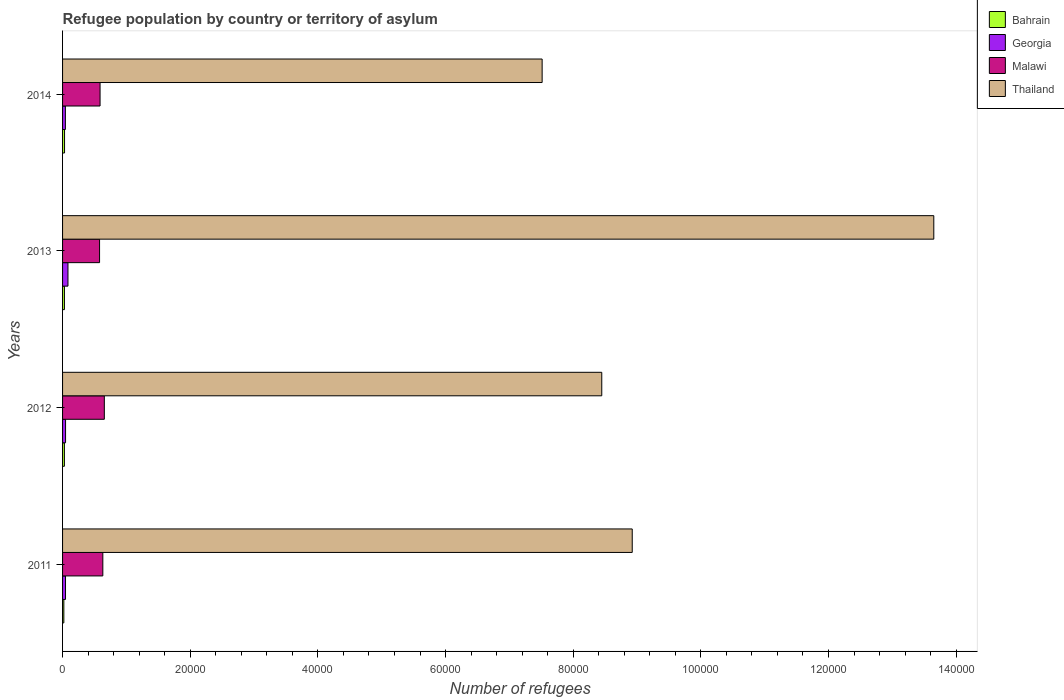How many different coloured bars are there?
Give a very brief answer. 4. How many groups of bars are there?
Your response must be concise. 4. Are the number of bars on each tick of the Y-axis equal?
Your answer should be very brief. Yes. How many bars are there on the 2nd tick from the top?
Keep it short and to the point. 4. How many bars are there on the 4th tick from the bottom?
Give a very brief answer. 4. What is the label of the 1st group of bars from the top?
Make the answer very short. 2014. In how many cases, is the number of bars for a given year not equal to the number of legend labels?
Your answer should be compact. 0. What is the number of refugees in Bahrain in 2014?
Offer a terse response. 311. Across all years, what is the maximum number of refugees in Bahrain?
Keep it short and to the point. 311. Across all years, what is the minimum number of refugees in Bahrain?
Keep it short and to the point. 199. In which year was the number of refugees in Malawi maximum?
Make the answer very short. 2012. What is the total number of refugees in Thailand in the graph?
Your answer should be very brief. 3.85e+05. What is the difference between the number of refugees in Bahrain in 2011 and that in 2012?
Keep it short and to the point. -90. What is the difference between the number of refugees in Georgia in 2011 and the number of refugees in Bahrain in 2013?
Offer a terse response. 168. What is the average number of refugees in Thailand per year?
Ensure brevity in your answer.  9.63e+04. In the year 2013, what is the difference between the number of refugees in Malawi and number of refugees in Georgia?
Keep it short and to the point. 4949. What is the ratio of the number of refugees in Bahrain in 2011 to that in 2012?
Your answer should be compact. 0.69. What is the difference between the highest and the lowest number of refugees in Thailand?
Provide a succinct answer. 6.14e+04. In how many years, is the number of refugees in Bahrain greater than the average number of refugees in Bahrain taken over all years?
Your answer should be compact. 3. Is the sum of the number of refugees in Thailand in 2013 and 2014 greater than the maximum number of refugees in Malawi across all years?
Your response must be concise. Yes. Is it the case that in every year, the sum of the number of refugees in Georgia and number of refugees in Malawi is greater than the sum of number of refugees in Thailand and number of refugees in Bahrain?
Offer a terse response. Yes. What does the 3rd bar from the top in 2013 represents?
Give a very brief answer. Georgia. What does the 1st bar from the bottom in 2014 represents?
Ensure brevity in your answer.  Bahrain. How many bars are there?
Offer a very short reply. 16. Are all the bars in the graph horizontal?
Make the answer very short. Yes. How many years are there in the graph?
Offer a terse response. 4. Are the values on the major ticks of X-axis written in scientific E-notation?
Keep it short and to the point. No. Does the graph contain any zero values?
Your response must be concise. No. Does the graph contain grids?
Ensure brevity in your answer.  No. How many legend labels are there?
Provide a short and direct response. 4. What is the title of the graph?
Ensure brevity in your answer.  Refugee population by country or territory of asylum. Does "Vanuatu" appear as one of the legend labels in the graph?
Provide a succinct answer. No. What is the label or title of the X-axis?
Give a very brief answer. Number of refugees. What is the label or title of the Y-axis?
Your answer should be very brief. Years. What is the Number of refugees of Bahrain in 2011?
Provide a succinct answer. 199. What is the Number of refugees in Georgia in 2011?
Make the answer very short. 462. What is the Number of refugees in Malawi in 2011?
Your answer should be very brief. 6308. What is the Number of refugees of Thailand in 2011?
Your response must be concise. 8.93e+04. What is the Number of refugees in Bahrain in 2012?
Offer a very short reply. 289. What is the Number of refugees in Georgia in 2012?
Make the answer very short. 469. What is the Number of refugees in Malawi in 2012?
Offer a very short reply. 6544. What is the Number of refugees of Thailand in 2012?
Provide a short and direct response. 8.45e+04. What is the Number of refugees in Bahrain in 2013?
Your answer should be very brief. 294. What is the Number of refugees in Georgia in 2013?
Offer a terse response. 847. What is the Number of refugees of Malawi in 2013?
Provide a short and direct response. 5796. What is the Number of refugees in Thailand in 2013?
Your response must be concise. 1.36e+05. What is the Number of refugees of Bahrain in 2014?
Your answer should be compact. 311. What is the Number of refugees of Georgia in 2014?
Make the answer very short. 442. What is the Number of refugees in Malawi in 2014?
Your answer should be compact. 5874. What is the Number of refugees in Thailand in 2014?
Give a very brief answer. 7.51e+04. Across all years, what is the maximum Number of refugees of Bahrain?
Provide a short and direct response. 311. Across all years, what is the maximum Number of refugees of Georgia?
Provide a short and direct response. 847. Across all years, what is the maximum Number of refugees of Malawi?
Make the answer very short. 6544. Across all years, what is the maximum Number of refugees in Thailand?
Provide a succinct answer. 1.36e+05. Across all years, what is the minimum Number of refugees in Bahrain?
Make the answer very short. 199. Across all years, what is the minimum Number of refugees of Georgia?
Ensure brevity in your answer.  442. Across all years, what is the minimum Number of refugees in Malawi?
Keep it short and to the point. 5796. Across all years, what is the minimum Number of refugees in Thailand?
Provide a succinct answer. 7.51e+04. What is the total Number of refugees of Bahrain in the graph?
Your answer should be very brief. 1093. What is the total Number of refugees in Georgia in the graph?
Provide a short and direct response. 2220. What is the total Number of refugees in Malawi in the graph?
Offer a terse response. 2.45e+04. What is the total Number of refugees of Thailand in the graph?
Give a very brief answer. 3.85e+05. What is the difference between the Number of refugees in Bahrain in 2011 and that in 2012?
Your answer should be very brief. -90. What is the difference between the Number of refugees in Georgia in 2011 and that in 2012?
Offer a terse response. -7. What is the difference between the Number of refugees of Malawi in 2011 and that in 2012?
Make the answer very short. -236. What is the difference between the Number of refugees of Thailand in 2011 and that in 2012?
Offer a terse response. 4774. What is the difference between the Number of refugees of Bahrain in 2011 and that in 2013?
Give a very brief answer. -95. What is the difference between the Number of refugees of Georgia in 2011 and that in 2013?
Make the answer very short. -385. What is the difference between the Number of refugees of Malawi in 2011 and that in 2013?
Provide a short and direct response. 512. What is the difference between the Number of refugees in Thailand in 2011 and that in 2013?
Provide a short and direct response. -4.72e+04. What is the difference between the Number of refugees in Bahrain in 2011 and that in 2014?
Keep it short and to the point. -112. What is the difference between the Number of refugees in Malawi in 2011 and that in 2014?
Offer a terse response. 434. What is the difference between the Number of refugees of Thailand in 2011 and that in 2014?
Make the answer very short. 1.41e+04. What is the difference between the Number of refugees of Bahrain in 2012 and that in 2013?
Provide a short and direct response. -5. What is the difference between the Number of refugees of Georgia in 2012 and that in 2013?
Provide a short and direct response. -378. What is the difference between the Number of refugees in Malawi in 2012 and that in 2013?
Give a very brief answer. 748. What is the difference between the Number of refugees of Thailand in 2012 and that in 2013?
Ensure brevity in your answer.  -5.20e+04. What is the difference between the Number of refugees in Malawi in 2012 and that in 2014?
Make the answer very short. 670. What is the difference between the Number of refugees of Thailand in 2012 and that in 2014?
Your answer should be compact. 9342. What is the difference between the Number of refugees of Georgia in 2013 and that in 2014?
Your answer should be compact. 405. What is the difference between the Number of refugees of Malawi in 2013 and that in 2014?
Ensure brevity in your answer.  -78. What is the difference between the Number of refugees of Thailand in 2013 and that in 2014?
Ensure brevity in your answer.  6.14e+04. What is the difference between the Number of refugees of Bahrain in 2011 and the Number of refugees of Georgia in 2012?
Make the answer very short. -270. What is the difference between the Number of refugees in Bahrain in 2011 and the Number of refugees in Malawi in 2012?
Your answer should be very brief. -6345. What is the difference between the Number of refugees of Bahrain in 2011 and the Number of refugees of Thailand in 2012?
Make the answer very short. -8.43e+04. What is the difference between the Number of refugees of Georgia in 2011 and the Number of refugees of Malawi in 2012?
Keep it short and to the point. -6082. What is the difference between the Number of refugees of Georgia in 2011 and the Number of refugees of Thailand in 2012?
Provide a short and direct response. -8.40e+04. What is the difference between the Number of refugees of Malawi in 2011 and the Number of refugees of Thailand in 2012?
Your answer should be compact. -7.82e+04. What is the difference between the Number of refugees in Bahrain in 2011 and the Number of refugees in Georgia in 2013?
Provide a short and direct response. -648. What is the difference between the Number of refugees in Bahrain in 2011 and the Number of refugees in Malawi in 2013?
Offer a terse response. -5597. What is the difference between the Number of refugees in Bahrain in 2011 and the Number of refugees in Thailand in 2013?
Keep it short and to the point. -1.36e+05. What is the difference between the Number of refugees of Georgia in 2011 and the Number of refugees of Malawi in 2013?
Your response must be concise. -5334. What is the difference between the Number of refugees in Georgia in 2011 and the Number of refugees in Thailand in 2013?
Make the answer very short. -1.36e+05. What is the difference between the Number of refugees in Malawi in 2011 and the Number of refugees in Thailand in 2013?
Provide a short and direct response. -1.30e+05. What is the difference between the Number of refugees in Bahrain in 2011 and the Number of refugees in Georgia in 2014?
Your answer should be compact. -243. What is the difference between the Number of refugees in Bahrain in 2011 and the Number of refugees in Malawi in 2014?
Your answer should be very brief. -5675. What is the difference between the Number of refugees of Bahrain in 2011 and the Number of refugees of Thailand in 2014?
Provide a short and direct response. -7.49e+04. What is the difference between the Number of refugees of Georgia in 2011 and the Number of refugees of Malawi in 2014?
Provide a short and direct response. -5412. What is the difference between the Number of refugees in Georgia in 2011 and the Number of refugees in Thailand in 2014?
Make the answer very short. -7.47e+04. What is the difference between the Number of refugees in Malawi in 2011 and the Number of refugees in Thailand in 2014?
Your response must be concise. -6.88e+04. What is the difference between the Number of refugees of Bahrain in 2012 and the Number of refugees of Georgia in 2013?
Your response must be concise. -558. What is the difference between the Number of refugees in Bahrain in 2012 and the Number of refugees in Malawi in 2013?
Keep it short and to the point. -5507. What is the difference between the Number of refugees of Bahrain in 2012 and the Number of refugees of Thailand in 2013?
Make the answer very short. -1.36e+05. What is the difference between the Number of refugees of Georgia in 2012 and the Number of refugees of Malawi in 2013?
Your answer should be compact. -5327. What is the difference between the Number of refugees in Georgia in 2012 and the Number of refugees in Thailand in 2013?
Ensure brevity in your answer.  -1.36e+05. What is the difference between the Number of refugees in Malawi in 2012 and the Number of refugees in Thailand in 2013?
Offer a terse response. -1.30e+05. What is the difference between the Number of refugees of Bahrain in 2012 and the Number of refugees of Georgia in 2014?
Offer a very short reply. -153. What is the difference between the Number of refugees in Bahrain in 2012 and the Number of refugees in Malawi in 2014?
Make the answer very short. -5585. What is the difference between the Number of refugees of Bahrain in 2012 and the Number of refugees of Thailand in 2014?
Provide a succinct answer. -7.48e+04. What is the difference between the Number of refugees in Georgia in 2012 and the Number of refugees in Malawi in 2014?
Your answer should be compact. -5405. What is the difference between the Number of refugees of Georgia in 2012 and the Number of refugees of Thailand in 2014?
Your response must be concise. -7.47e+04. What is the difference between the Number of refugees of Malawi in 2012 and the Number of refugees of Thailand in 2014?
Make the answer very short. -6.86e+04. What is the difference between the Number of refugees in Bahrain in 2013 and the Number of refugees in Georgia in 2014?
Your answer should be very brief. -148. What is the difference between the Number of refugees in Bahrain in 2013 and the Number of refugees in Malawi in 2014?
Keep it short and to the point. -5580. What is the difference between the Number of refugees in Bahrain in 2013 and the Number of refugees in Thailand in 2014?
Keep it short and to the point. -7.48e+04. What is the difference between the Number of refugees of Georgia in 2013 and the Number of refugees of Malawi in 2014?
Provide a short and direct response. -5027. What is the difference between the Number of refugees in Georgia in 2013 and the Number of refugees in Thailand in 2014?
Your answer should be very brief. -7.43e+04. What is the difference between the Number of refugees of Malawi in 2013 and the Number of refugees of Thailand in 2014?
Offer a terse response. -6.93e+04. What is the average Number of refugees of Bahrain per year?
Provide a succinct answer. 273.25. What is the average Number of refugees of Georgia per year?
Provide a short and direct response. 555. What is the average Number of refugees of Malawi per year?
Offer a terse response. 6130.5. What is the average Number of refugees of Thailand per year?
Your answer should be very brief. 9.63e+04. In the year 2011, what is the difference between the Number of refugees in Bahrain and Number of refugees in Georgia?
Your answer should be very brief. -263. In the year 2011, what is the difference between the Number of refugees of Bahrain and Number of refugees of Malawi?
Offer a very short reply. -6109. In the year 2011, what is the difference between the Number of refugees in Bahrain and Number of refugees in Thailand?
Provide a succinct answer. -8.91e+04. In the year 2011, what is the difference between the Number of refugees of Georgia and Number of refugees of Malawi?
Your response must be concise. -5846. In the year 2011, what is the difference between the Number of refugees in Georgia and Number of refugees in Thailand?
Your answer should be very brief. -8.88e+04. In the year 2011, what is the difference between the Number of refugees of Malawi and Number of refugees of Thailand?
Offer a terse response. -8.29e+04. In the year 2012, what is the difference between the Number of refugees in Bahrain and Number of refugees in Georgia?
Your answer should be compact. -180. In the year 2012, what is the difference between the Number of refugees of Bahrain and Number of refugees of Malawi?
Your response must be concise. -6255. In the year 2012, what is the difference between the Number of refugees of Bahrain and Number of refugees of Thailand?
Offer a terse response. -8.42e+04. In the year 2012, what is the difference between the Number of refugees in Georgia and Number of refugees in Malawi?
Offer a very short reply. -6075. In the year 2012, what is the difference between the Number of refugees in Georgia and Number of refugees in Thailand?
Offer a very short reply. -8.40e+04. In the year 2012, what is the difference between the Number of refugees in Malawi and Number of refugees in Thailand?
Give a very brief answer. -7.79e+04. In the year 2013, what is the difference between the Number of refugees in Bahrain and Number of refugees in Georgia?
Give a very brief answer. -553. In the year 2013, what is the difference between the Number of refugees in Bahrain and Number of refugees in Malawi?
Your answer should be compact. -5502. In the year 2013, what is the difference between the Number of refugees in Bahrain and Number of refugees in Thailand?
Ensure brevity in your answer.  -1.36e+05. In the year 2013, what is the difference between the Number of refugees in Georgia and Number of refugees in Malawi?
Keep it short and to the point. -4949. In the year 2013, what is the difference between the Number of refugees of Georgia and Number of refugees of Thailand?
Offer a terse response. -1.36e+05. In the year 2013, what is the difference between the Number of refugees of Malawi and Number of refugees of Thailand?
Your response must be concise. -1.31e+05. In the year 2014, what is the difference between the Number of refugees in Bahrain and Number of refugees in Georgia?
Provide a succinct answer. -131. In the year 2014, what is the difference between the Number of refugees in Bahrain and Number of refugees in Malawi?
Your answer should be very brief. -5563. In the year 2014, what is the difference between the Number of refugees in Bahrain and Number of refugees in Thailand?
Offer a terse response. -7.48e+04. In the year 2014, what is the difference between the Number of refugees in Georgia and Number of refugees in Malawi?
Give a very brief answer. -5432. In the year 2014, what is the difference between the Number of refugees in Georgia and Number of refugees in Thailand?
Your answer should be very brief. -7.47e+04. In the year 2014, what is the difference between the Number of refugees of Malawi and Number of refugees of Thailand?
Keep it short and to the point. -6.93e+04. What is the ratio of the Number of refugees of Bahrain in 2011 to that in 2012?
Offer a very short reply. 0.69. What is the ratio of the Number of refugees in Georgia in 2011 to that in 2012?
Provide a short and direct response. 0.99. What is the ratio of the Number of refugees of Malawi in 2011 to that in 2012?
Give a very brief answer. 0.96. What is the ratio of the Number of refugees in Thailand in 2011 to that in 2012?
Offer a terse response. 1.06. What is the ratio of the Number of refugees of Bahrain in 2011 to that in 2013?
Your response must be concise. 0.68. What is the ratio of the Number of refugees of Georgia in 2011 to that in 2013?
Keep it short and to the point. 0.55. What is the ratio of the Number of refugees in Malawi in 2011 to that in 2013?
Your answer should be compact. 1.09. What is the ratio of the Number of refugees of Thailand in 2011 to that in 2013?
Offer a very short reply. 0.65. What is the ratio of the Number of refugees of Bahrain in 2011 to that in 2014?
Your response must be concise. 0.64. What is the ratio of the Number of refugees of Georgia in 2011 to that in 2014?
Your answer should be compact. 1.05. What is the ratio of the Number of refugees in Malawi in 2011 to that in 2014?
Provide a short and direct response. 1.07. What is the ratio of the Number of refugees in Thailand in 2011 to that in 2014?
Your response must be concise. 1.19. What is the ratio of the Number of refugees in Georgia in 2012 to that in 2013?
Provide a short and direct response. 0.55. What is the ratio of the Number of refugees of Malawi in 2012 to that in 2013?
Provide a succinct answer. 1.13. What is the ratio of the Number of refugees in Thailand in 2012 to that in 2013?
Your answer should be compact. 0.62. What is the ratio of the Number of refugees in Bahrain in 2012 to that in 2014?
Ensure brevity in your answer.  0.93. What is the ratio of the Number of refugees of Georgia in 2012 to that in 2014?
Your answer should be very brief. 1.06. What is the ratio of the Number of refugees of Malawi in 2012 to that in 2014?
Ensure brevity in your answer.  1.11. What is the ratio of the Number of refugees of Thailand in 2012 to that in 2014?
Make the answer very short. 1.12. What is the ratio of the Number of refugees of Bahrain in 2013 to that in 2014?
Offer a very short reply. 0.95. What is the ratio of the Number of refugees in Georgia in 2013 to that in 2014?
Give a very brief answer. 1.92. What is the ratio of the Number of refugees of Malawi in 2013 to that in 2014?
Your answer should be compact. 0.99. What is the ratio of the Number of refugees of Thailand in 2013 to that in 2014?
Offer a very short reply. 1.82. What is the difference between the highest and the second highest Number of refugees of Georgia?
Offer a very short reply. 378. What is the difference between the highest and the second highest Number of refugees of Malawi?
Your response must be concise. 236. What is the difference between the highest and the second highest Number of refugees of Thailand?
Provide a succinct answer. 4.72e+04. What is the difference between the highest and the lowest Number of refugees of Bahrain?
Make the answer very short. 112. What is the difference between the highest and the lowest Number of refugees of Georgia?
Keep it short and to the point. 405. What is the difference between the highest and the lowest Number of refugees of Malawi?
Make the answer very short. 748. What is the difference between the highest and the lowest Number of refugees in Thailand?
Offer a terse response. 6.14e+04. 